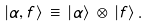<formula> <loc_0><loc_0><loc_500><loc_500>| \alpha , f \rangle \, \equiv \, | \alpha \rangle \, \otimes \, | f \rangle \, .</formula> 